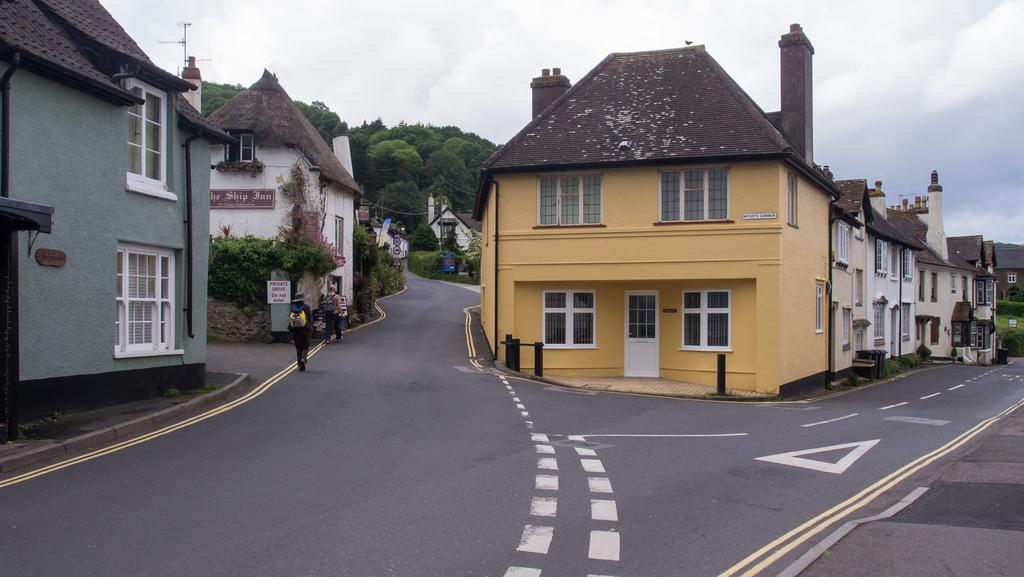What type of structures can be seen in the image? There are buildings in the image. What natural elements are present in the image? There are trees and plants in the image. What are the two persons in the image doing? They are walking on the road in the image. What is visible in the sky at the top of the image? There are clouds in the sky at the top of the image. Can you see a mountain in the image? There is no mountain present in the image. How many drops of water can be seen falling from the clouds in the image? There are no drops of water visible in the image; only clouds are present in the sky. 